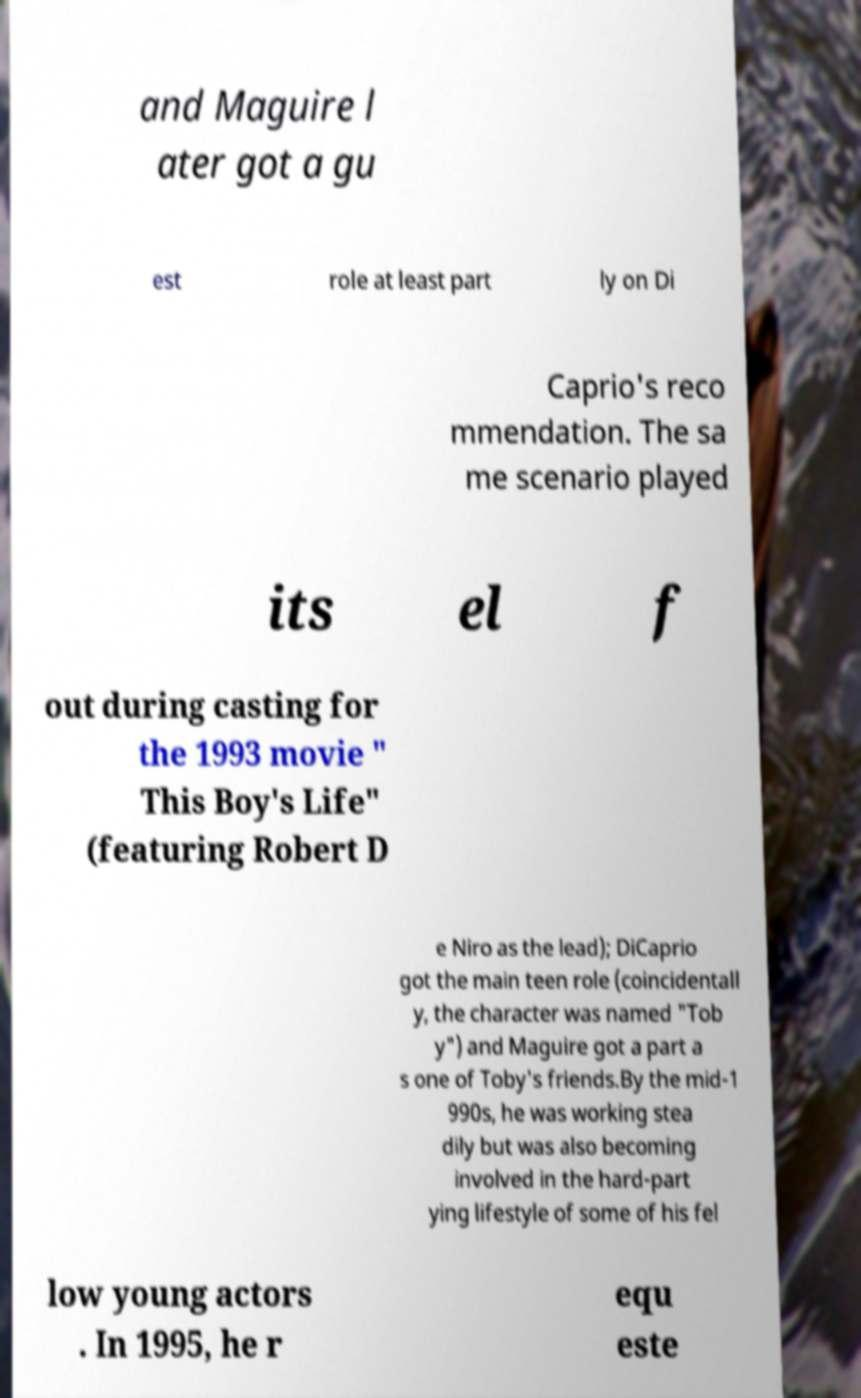Could you extract and type out the text from this image? and Maguire l ater got a gu est role at least part ly on Di Caprio's reco mmendation. The sa me scenario played its el f out during casting for the 1993 movie " This Boy's Life" (featuring Robert D e Niro as the lead); DiCaprio got the main teen role (coincidentall y, the character was named "Tob y") and Maguire got a part a s one of Toby's friends.By the mid-1 990s, he was working stea dily but was also becoming involved in the hard-part ying lifestyle of some of his fel low young actors . In 1995, he r equ este 